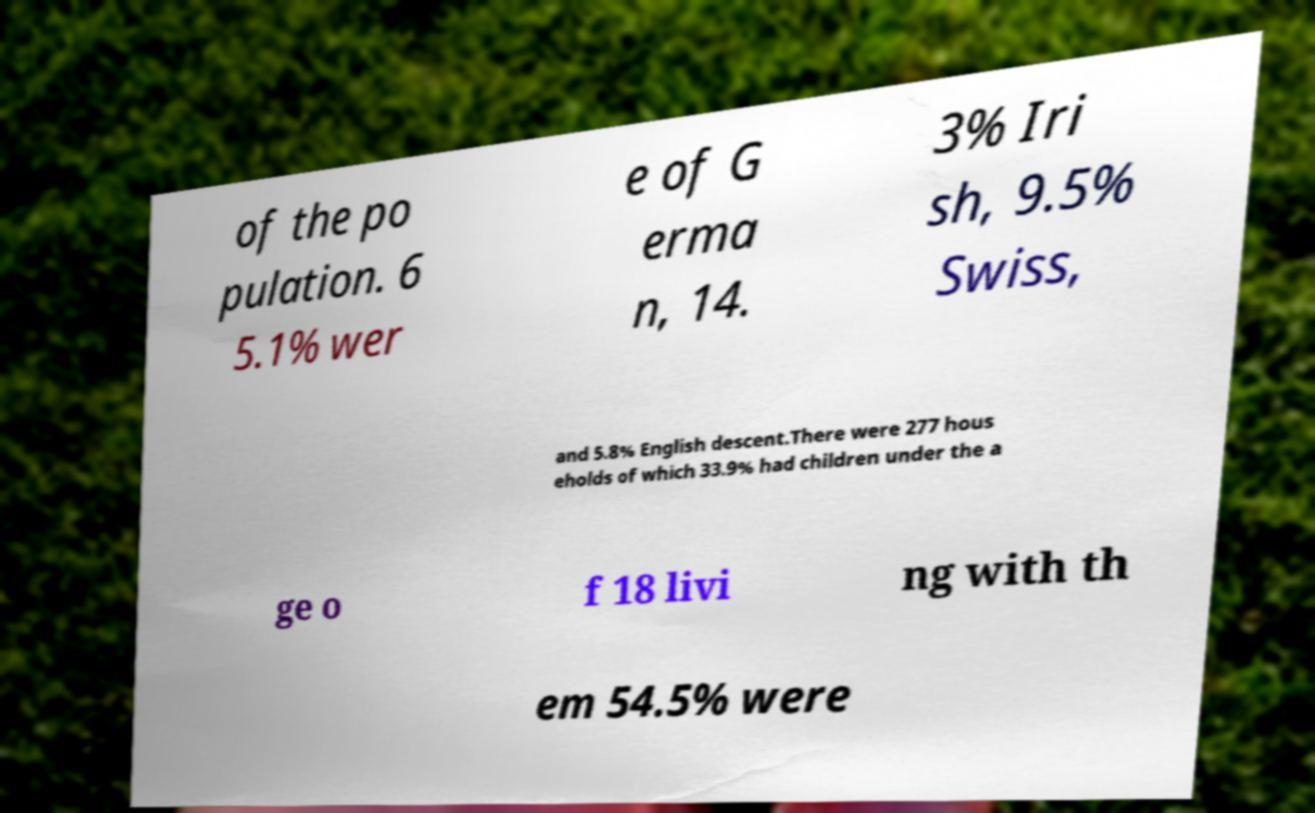For documentation purposes, I need the text within this image transcribed. Could you provide that? of the po pulation. 6 5.1% wer e of G erma n, 14. 3% Iri sh, 9.5% Swiss, and 5.8% English descent.There were 277 hous eholds of which 33.9% had children under the a ge o f 18 livi ng with th em 54.5% were 